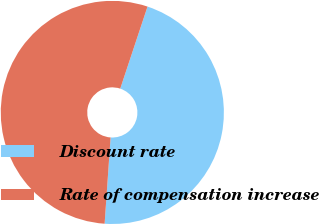Convert chart to OTSL. <chart><loc_0><loc_0><loc_500><loc_500><pie_chart><fcel>Discount rate<fcel>Rate of compensation increase<nl><fcel>45.99%<fcel>54.01%<nl></chart> 